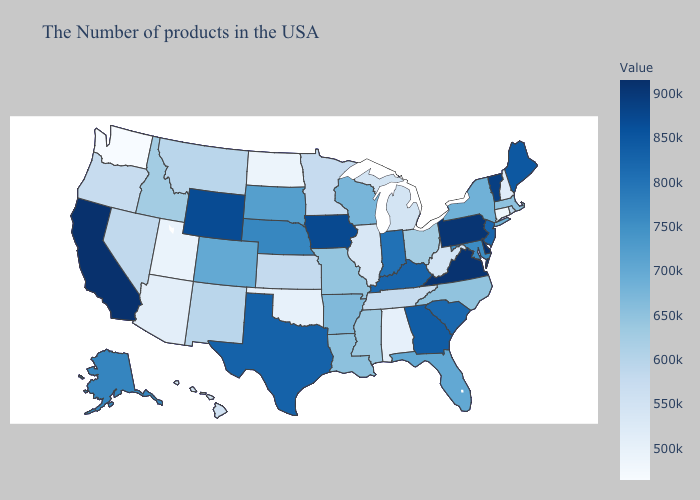Does Washington have the lowest value in the West?
Answer briefly. Yes. Does Missouri have the lowest value in the MidWest?
Keep it brief. No. Among the states that border New York , does Massachusetts have the highest value?
Short answer required. No. Does Maryland have the lowest value in the South?
Keep it brief. No. 